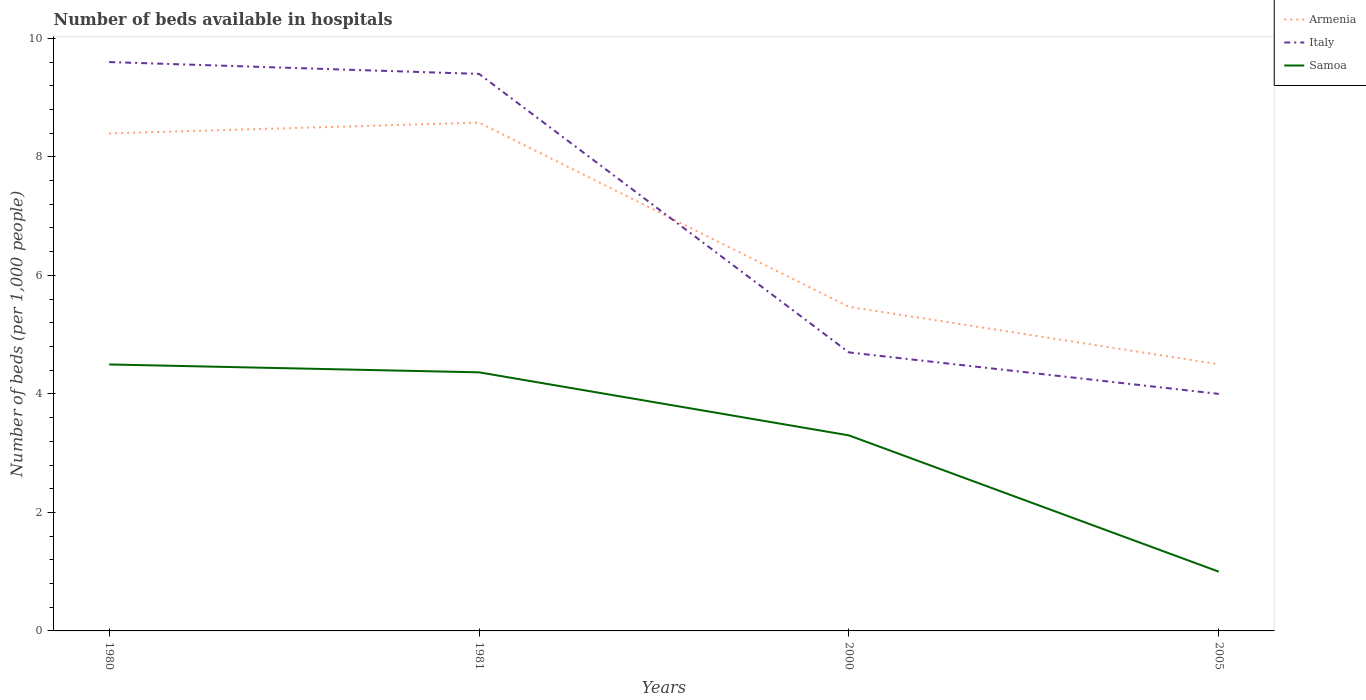Does the line corresponding to Armenia intersect with the line corresponding to Samoa?
Provide a short and direct response. No. In which year was the number of beds in the hospiatls of in Armenia maximum?
Give a very brief answer. 2005. What is the total number of beds in the hospiatls of in Italy in the graph?
Provide a succinct answer. 5.6. What is the difference between the highest and the second highest number of beds in the hospiatls of in Italy?
Offer a terse response. 5.6. What is the difference between the highest and the lowest number of beds in the hospiatls of in Samoa?
Ensure brevity in your answer.  3. What is the difference between two consecutive major ticks on the Y-axis?
Keep it short and to the point. 2. Does the graph contain any zero values?
Keep it short and to the point. No. Does the graph contain grids?
Offer a terse response. No. What is the title of the graph?
Give a very brief answer. Number of beds available in hospitals. What is the label or title of the Y-axis?
Provide a succinct answer. Number of beds (per 1,0 people). What is the Number of beds (per 1,000 people) of Armenia in 1980?
Make the answer very short. 8.4. What is the Number of beds (per 1,000 people) of Italy in 1980?
Give a very brief answer. 9.6. What is the Number of beds (per 1,000 people) in Samoa in 1980?
Ensure brevity in your answer.  4.5. What is the Number of beds (per 1,000 people) in Armenia in 1981?
Your answer should be very brief. 8.58. What is the Number of beds (per 1,000 people) of Italy in 1981?
Provide a short and direct response. 9.4. What is the Number of beds (per 1,000 people) in Samoa in 1981?
Provide a succinct answer. 4.36. What is the Number of beds (per 1,000 people) in Armenia in 2000?
Your answer should be compact. 5.47. What is the Number of beds (per 1,000 people) of Italy in 2000?
Give a very brief answer. 4.7. What is the Number of beds (per 1,000 people) in Samoa in 2000?
Ensure brevity in your answer.  3.3. What is the Number of beds (per 1,000 people) of Armenia in 2005?
Keep it short and to the point. 4.5. What is the Number of beds (per 1,000 people) of Samoa in 2005?
Your answer should be very brief. 1. Across all years, what is the maximum Number of beds (per 1,000 people) of Armenia?
Ensure brevity in your answer.  8.58. Across all years, what is the maximum Number of beds (per 1,000 people) of Italy?
Your answer should be very brief. 9.6. Across all years, what is the maximum Number of beds (per 1,000 people) in Samoa?
Provide a short and direct response. 4.5. Across all years, what is the minimum Number of beds (per 1,000 people) in Italy?
Provide a short and direct response. 4. Across all years, what is the minimum Number of beds (per 1,000 people) of Samoa?
Keep it short and to the point. 1. What is the total Number of beds (per 1,000 people) in Armenia in the graph?
Make the answer very short. 26.94. What is the total Number of beds (per 1,000 people) of Italy in the graph?
Your answer should be very brief. 27.7. What is the total Number of beds (per 1,000 people) of Samoa in the graph?
Offer a very short reply. 13.16. What is the difference between the Number of beds (per 1,000 people) of Armenia in 1980 and that in 1981?
Ensure brevity in your answer.  -0.18. What is the difference between the Number of beds (per 1,000 people) in Italy in 1980 and that in 1981?
Keep it short and to the point. 0.2. What is the difference between the Number of beds (per 1,000 people) of Samoa in 1980 and that in 1981?
Offer a very short reply. 0.13. What is the difference between the Number of beds (per 1,000 people) of Armenia in 1980 and that in 2000?
Ensure brevity in your answer.  2.93. What is the difference between the Number of beds (per 1,000 people) of Italy in 1980 and that in 2000?
Offer a terse response. 4.9. What is the difference between the Number of beds (per 1,000 people) in Samoa in 1980 and that in 2000?
Ensure brevity in your answer.  1.2. What is the difference between the Number of beds (per 1,000 people) in Armenia in 1980 and that in 2005?
Keep it short and to the point. 3.9. What is the difference between the Number of beds (per 1,000 people) in Italy in 1980 and that in 2005?
Your answer should be very brief. 5.6. What is the difference between the Number of beds (per 1,000 people) of Samoa in 1980 and that in 2005?
Offer a very short reply. 3.5. What is the difference between the Number of beds (per 1,000 people) in Armenia in 1981 and that in 2000?
Offer a terse response. 3.11. What is the difference between the Number of beds (per 1,000 people) of Italy in 1981 and that in 2000?
Your answer should be compact. 4.7. What is the difference between the Number of beds (per 1,000 people) of Samoa in 1981 and that in 2000?
Provide a short and direct response. 1.06. What is the difference between the Number of beds (per 1,000 people) in Armenia in 1981 and that in 2005?
Make the answer very short. 4.08. What is the difference between the Number of beds (per 1,000 people) of Samoa in 1981 and that in 2005?
Keep it short and to the point. 3.36. What is the difference between the Number of beds (per 1,000 people) of Armenia in 1980 and the Number of beds (per 1,000 people) of Italy in 1981?
Offer a terse response. -1. What is the difference between the Number of beds (per 1,000 people) in Armenia in 1980 and the Number of beds (per 1,000 people) in Samoa in 1981?
Offer a terse response. 4.03. What is the difference between the Number of beds (per 1,000 people) of Italy in 1980 and the Number of beds (per 1,000 people) of Samoa in 1981?
Keep it short and to the point. 5.24. What is the difference between the Number of beds (per 1,000 people) in Armenia in 1980 and the Number of beds (per 1,000 people) in Italy in 2000?
Your response must be concise. 3.7. What is the difference between the Number of beds (per 1,000 people) in Armenia in 1980 and the Number of beds (per 1,000 people) in Samoa in 2000?
Your response must be concise. 5.1. What is the difference between the Number of beds (per 1,000 people) in Italy in 1980 and the Number of beds (per 1,000 people) in Samoa in 2000?
Your answer should be compact. 6.3. What is the difference between the Number of beds (per 1,000 people) of Armenia in 1980 and the Number of beds (per 1,000 people) of Italy in 2005?
Provide a succinct answer. 4.4. What is the difference between the Number of beds (per 1,000 people) in Armenia in 1980 and the Number of beds (per 1,000 people) in Samoa in 2005?
Make the answer very short. 7.4. What is the difference between the Number of beds (per 1,000 people) in Armenia in 1981 and the Number of beds (per 1,000 people) in Italy in 2000?
Provide a succinct answer. 3.88. What is the difference between the Number of beds (per 1,000 people) in Armenia in 1981 and the Number of beds (per 1,000 people) in Samoa in 2000?
Your answer should be compact. 5.28. What is the difference between the Number of beds (per 1,000 people) in Armenia in 1981 and the Number of beds (per 1,000 people) in Italy in 2005?
Your answer should be very brief. 4.58. What is the difference between the Number of beds (per 1,000 people) of Armenia in 1981 and the Number of beds (per 1,000 people) of Samoa in 2005?
Make the answer very short. 7.58. What is the difference between the Number of beds (per 1,000 people) in Italy in 1981 and the Number of beds (per 1,000 people) in Samoa in 2005?
Provide a succinct answer. 8.4. What is the difference between the Number of beds (per 1,000 people) of Armenia in 2000 and the Number of beds (per 1,000 people) of Italy in 2005?
Your answer should be compact. 1.47. What is the difference between the Number of beds (per 1,000 people) of Armenia in 2000 and the Number of beds (per 1,000 people) of Samoa in 2005?
Offer a very short reply. 4.47. What is the average Number of beds (per 1,000 people) in Armenia per year?
Make the answer very short. 6.74. What is the average Number of beds (per 1,000 people) of Italy per year?
Keep it short and to the point. 6.92. What is the average Number of beds (per 1,000 people) of Samoa per year?
Your answer should be very brief. 3.29. In the year 1980, what is the difference between the Number of beds (per 1,000 people) in Armenia and Number of beds (per 1,000 people) in Italy?
Provide a short and direct response. -1.2. In the year 1980, what is the difference between the Number of beds (per 1,000 people) of Armenia and Number of beds (per 1,000 people) of Samoa?
Keep it short and to the point. 3.9. In the year 1980, what is the difference between the Number of beds (per 1,000 people) in Italy and Number of beds (per 1,000 people) in Samoa?
Your answer should be very brief. 5.1. In the year 1981, what is the difference between the Number of beds (per 1,000 people) of Armenia and Number of beds (per 1,000 people) of Italy?
Your answer should be very brief. -0.82. In the year 1981, what is the difference between the Number of beds (per 1,000 people) of Armenia and Number of beds (per 1,000 people) of Samoa?
Make the answer very short. 4.21. In the year 1981, what is the difference between the Number of beds (per 1,000 people) in Italy and Number of beds (per 1,000 people) in Samoa?
Offer a very short reply. 5.04. In the year 2000, what is the difference between the Number of beds (per 1,000 people) in Armenia and Number of beds (per 1,000 people) in Italy?
Provide a short and direct response. 0.77. In the year 2000, what is the difference between the Number of beds (per 1,000 people) of Armenia and Number of beds (per 1,000 people) of Samoa?
Ensure brevity in your answer.  2.17. What is the ratio of the Number of beds (per 1,000 people) in Armenia in 1980 to that in 1981?
Provide a short and direct response. 0.98. What is the ratio of the Number of beds (per 1,000 people) in Italy in 1980 to that in 1981?
Provide a short and direct response. 1.02. What is the ratio of the Number of beds (per 1,000 people) of Samoa in 1980 to that in 1981?
Make the answer very short. 1.03. What is the ratio of the Number of beds (per 1,000 people) in Armenia in 1980 to that in 2000?
Your answer should be compact. 1.53. What is the ratio of the Number of beds (per 1,000 people) of Italy in 1980 to that in 2000?
Ensure brevity in your answer.  2.04. What is the ratio of the Number of beds (per 1,000 people) in Samoa in 1980 to that in 2000?
Your answer should be very brief. 1.36. What is the ratio of the Number of beds (per 1,000 people) in Armenia in 1980 to that in 2005?
Keep it short and to the point. 1.87. What is the ratio of the Number of beds (per 1,000 people) in Samoa in 1980 to that in 2005?
Your answer should be compact. 4.5. What is the ratio of the Number of beds (per 1,000 people) in Armenia in 1981 to that in 2000?
Provide a short and direct response. 1.57. What is the ratio of the Number of beds (per 1,000 people) of Italy in 1981 to that in 2000?
Provide a succinct answer. 2. What is the ratio of the Number of beds (per 1,000 people) in Samoa in 1981 to that in 2000?
Make the answer very short. 1.32. What is the ratio of the Number of beds (per 1,000 people) of Armenia in 1981 to that in 2005?
Provide a succinct answer. 1.91. What is the ratio of the Number of beds (per 1,000 people) of Italy in 1981 to that in 2005?
Offer a very short reply. 2.35. What is the ratio of the Number of beds (per 1,000 people) of Samoa in 1981 to that in 2005?
Give a very brief answer. 4.36. What is the ratio of the Number of beds (per 1,000 people) of Armenia in 2000 to that in 2005?
Your answer should be very brief. 1.22. What is the ratio of the Number of beds (per 1,000 people) of Italy in 2000 to that in 2005?
Ensure brevity in your answer.  1.18. What is the ratio of the Number of beds (per 1,000 people) in Samoa in 2000 to that in 2005?
Provide a short and direct response. 3.3. What is the difference between the highest and the second highest Number of beds (per 1,000 people) in Armenia?
Your answer should be compact. 0.18. What is the difference between the highest and the second highest Number of beds (per 1,000 people) in Samoa?
Make the answer very short. 0.13. What is the difference between the highest and the lowest Number of beds (per 1,000 people) of Armenia?
Your answer should be very brief. 4.08. What is the difference between the highest and the lowest Number of beds (per 1,000 people) of Italy?
Provide a short and direct response. 5.6. What is the difference between the highest and the lowest Number of beds (per 1,000 people) of Samoa?
Your answer should be very brief. 3.5. 